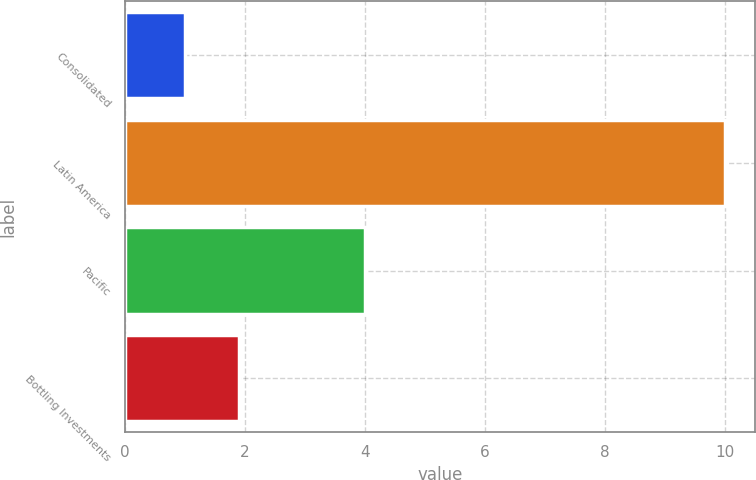<chart> <loc_0><loc_0><loc_500><loc_500><bar_chart><fcel>Consolidated<fcel>Latin America<fcel>Pacific<fcel>Bottling Investments<nl><fcel>1<fcel>10<fcel>4<fcel>1.9<nl></chart> 